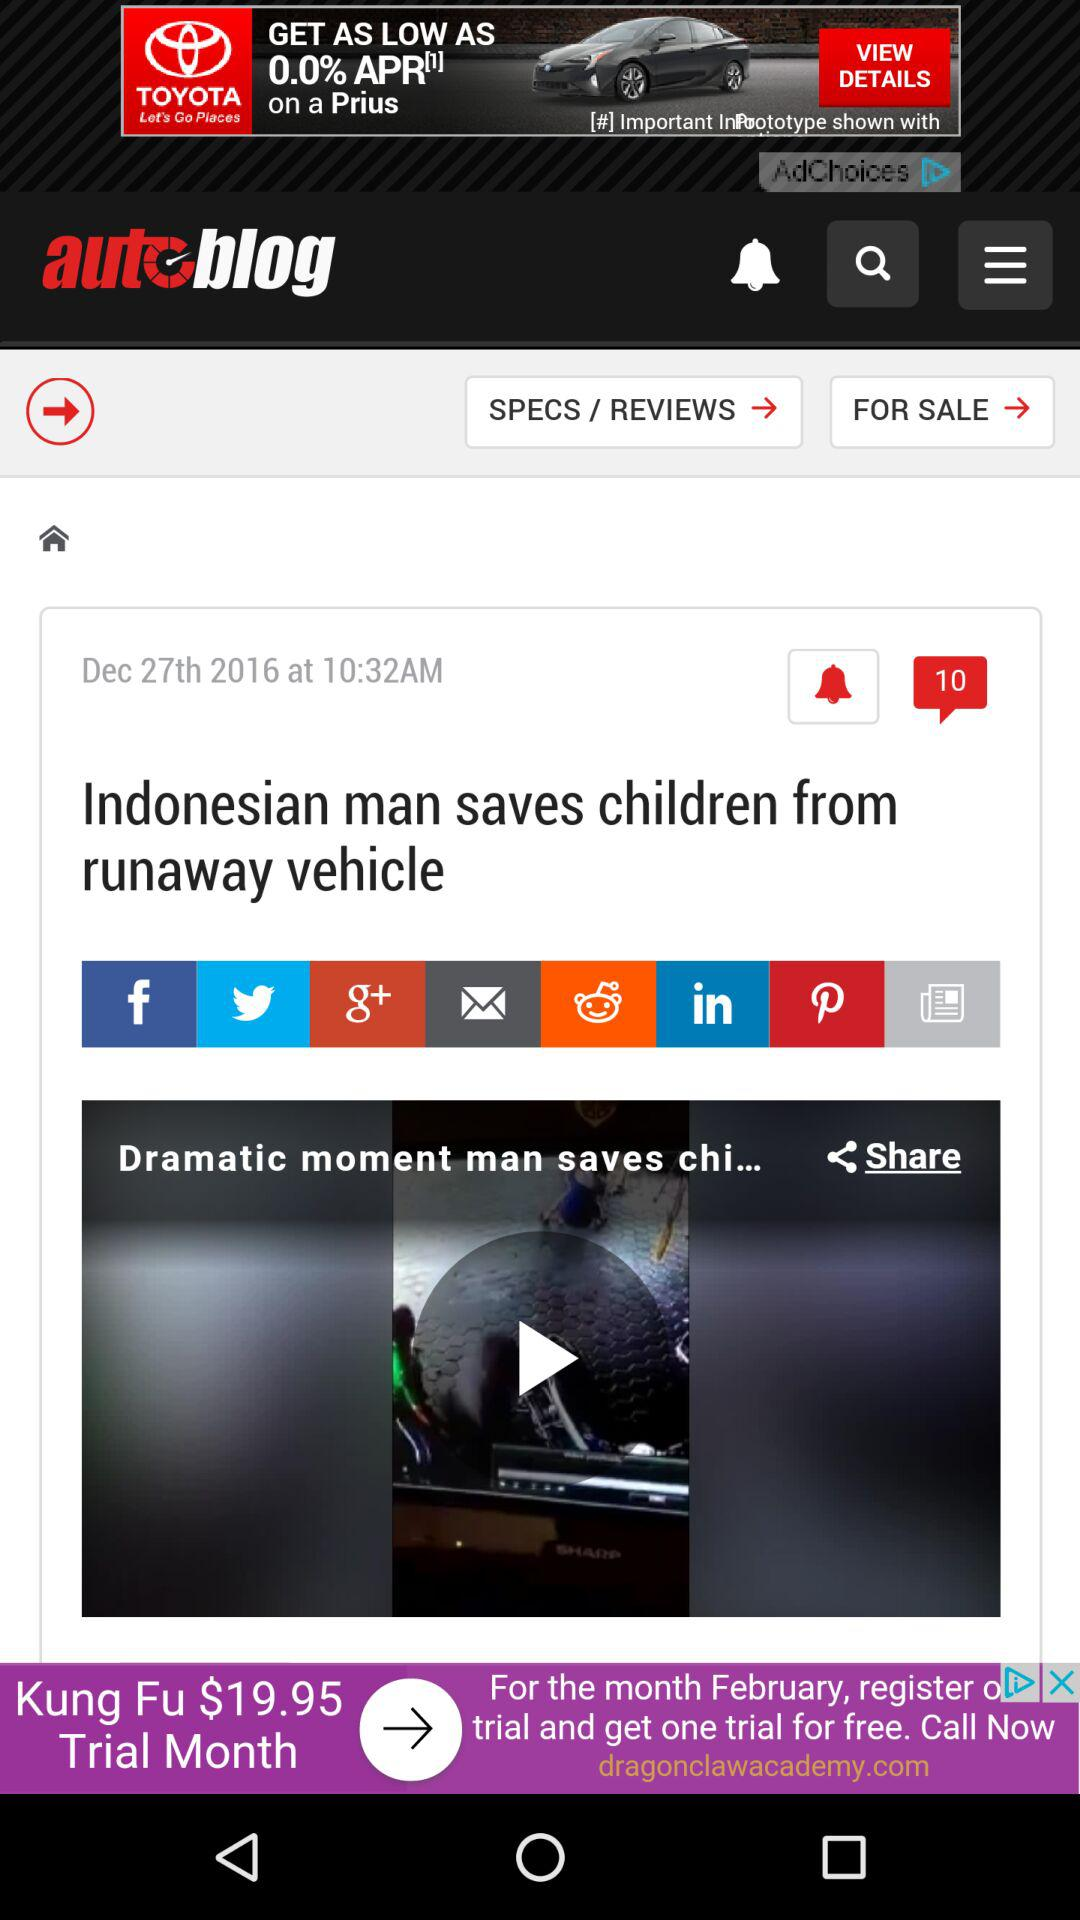How many comments are there? There are 10 comments. 